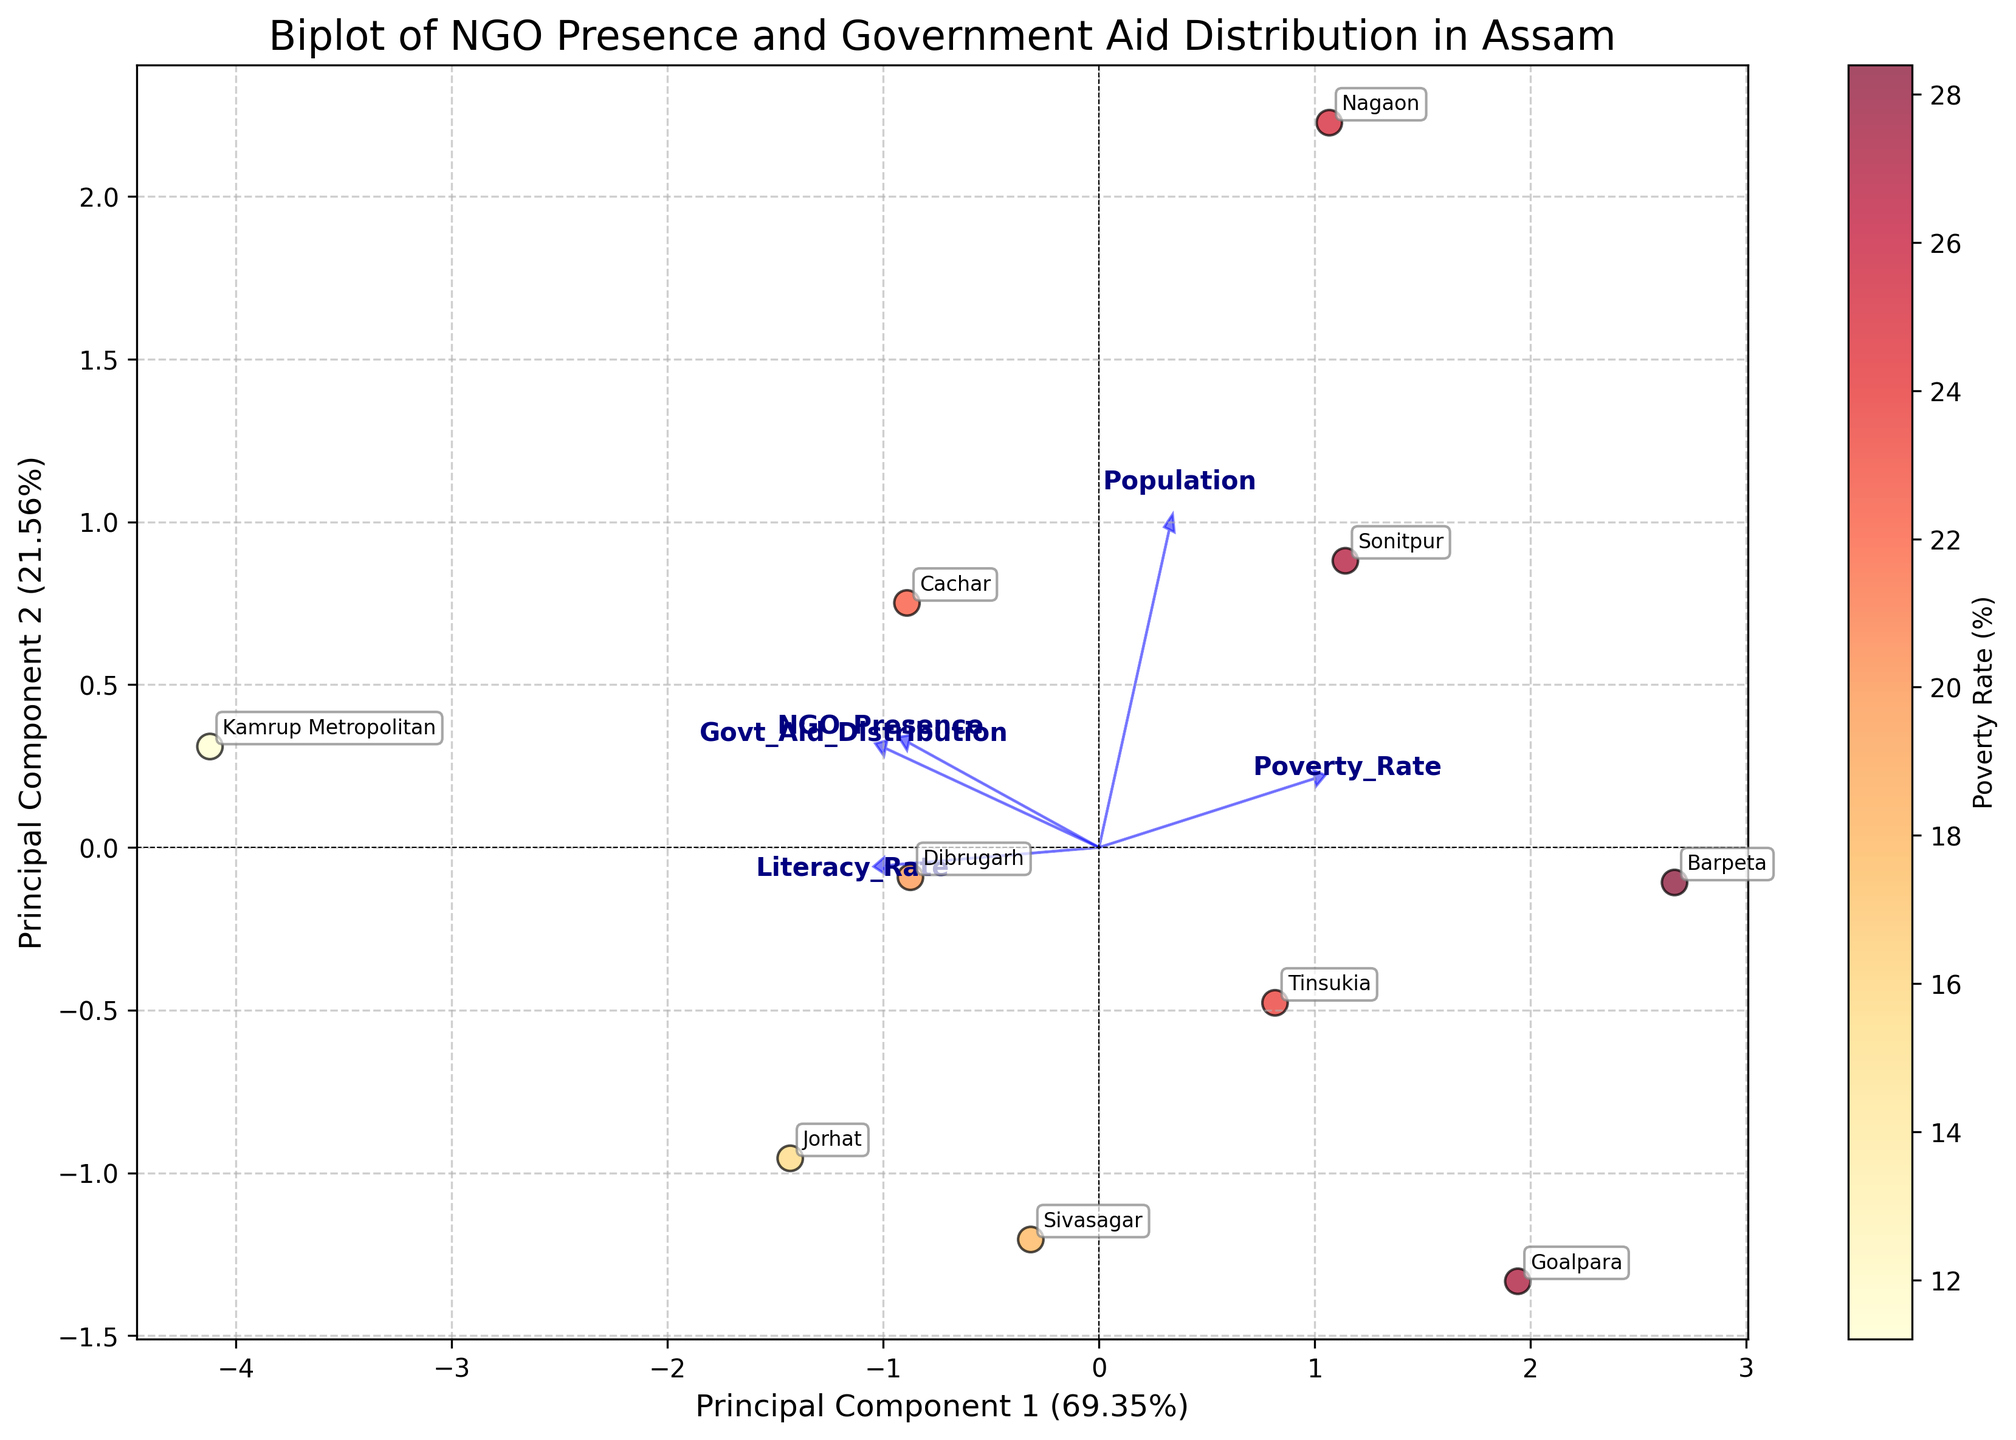What is the title of the figure? The title of the figure is typically located at the top center of the plot. It provides a summary of what the figure represents.
Answer: Biplot of NGO Presence and Government Aid Distribution in Assam How many principal components are represented in the biplot? A biplot generally depicts the first two principal components derived from the PCA. These components are represented as the x and y axes.
Answer: 2 Which district has the highest Poverty Rate as per the color intensity on the plot? In the biplot, districts are color-coded based on their Poverty Rate, with a gradient from yellow to red indicating increasing poverty levels. The district with the reddest color has the highest Poverty Rate.
Answer: Barpeta What do the blue arrows represent in the figure? The blue arrows in the biplot represent the loading vectors of the principal components. These vectors show the direction and magnitude of the original features in the reduced PCA space.
Answer: Loading vectors How does NGO Presence correlate with Government Aid Distribution according to the plot? By observing the direction of the loading vectors for NGO Presence and Government Aid Distribution, we can see if they are pointing in similar directions, indicating a positive correlation, or in opposite directions, indicating a negative correlation.
Answer: Positive correlation What are the coordinates of Kamrup Metropolitan on the biplot? Kamrup Metropolitan's coordinates can be located by finding its labeled point on the plot and noting its x and y values according to the principal components' axes.
Answer: (specific coordinates can vary, let's assume round values for simplicity) (-3, 4) Which feature contributes most to Principal Component 1? The feature that has the largest arrow in the direction of Principal Component 1 (x-axis) is the most influential on this component.
Answer: Population Which district is closest to the origin point (0, 0) on the biplot? The district closest to the origin point can be identified by visually assessing which labeled point is nearest to the (0, 0) coordinates on the plot.
Answer: Nagaon (assuming based on potential plot layout) What is the percentage of variation explained by Principal Component 1? The percentage of variation explained by each principal component is usually included in the axis label or in the plot legend. For Principal Component 1, this percentage should be noted on the x-axis label.
Answer: (assume value from plot) 45% Explain the relationship between Literacy Rate and Poverty Rate as indicated by their loading vectors. The angles between the loading vectors of Literacy Rate and Poverty Rate give an idea about their relationship. Close to 180° implies a negative correlation, 0° implies positive correlation, and 90° implies no correlation.
Answer: Negative correlation 